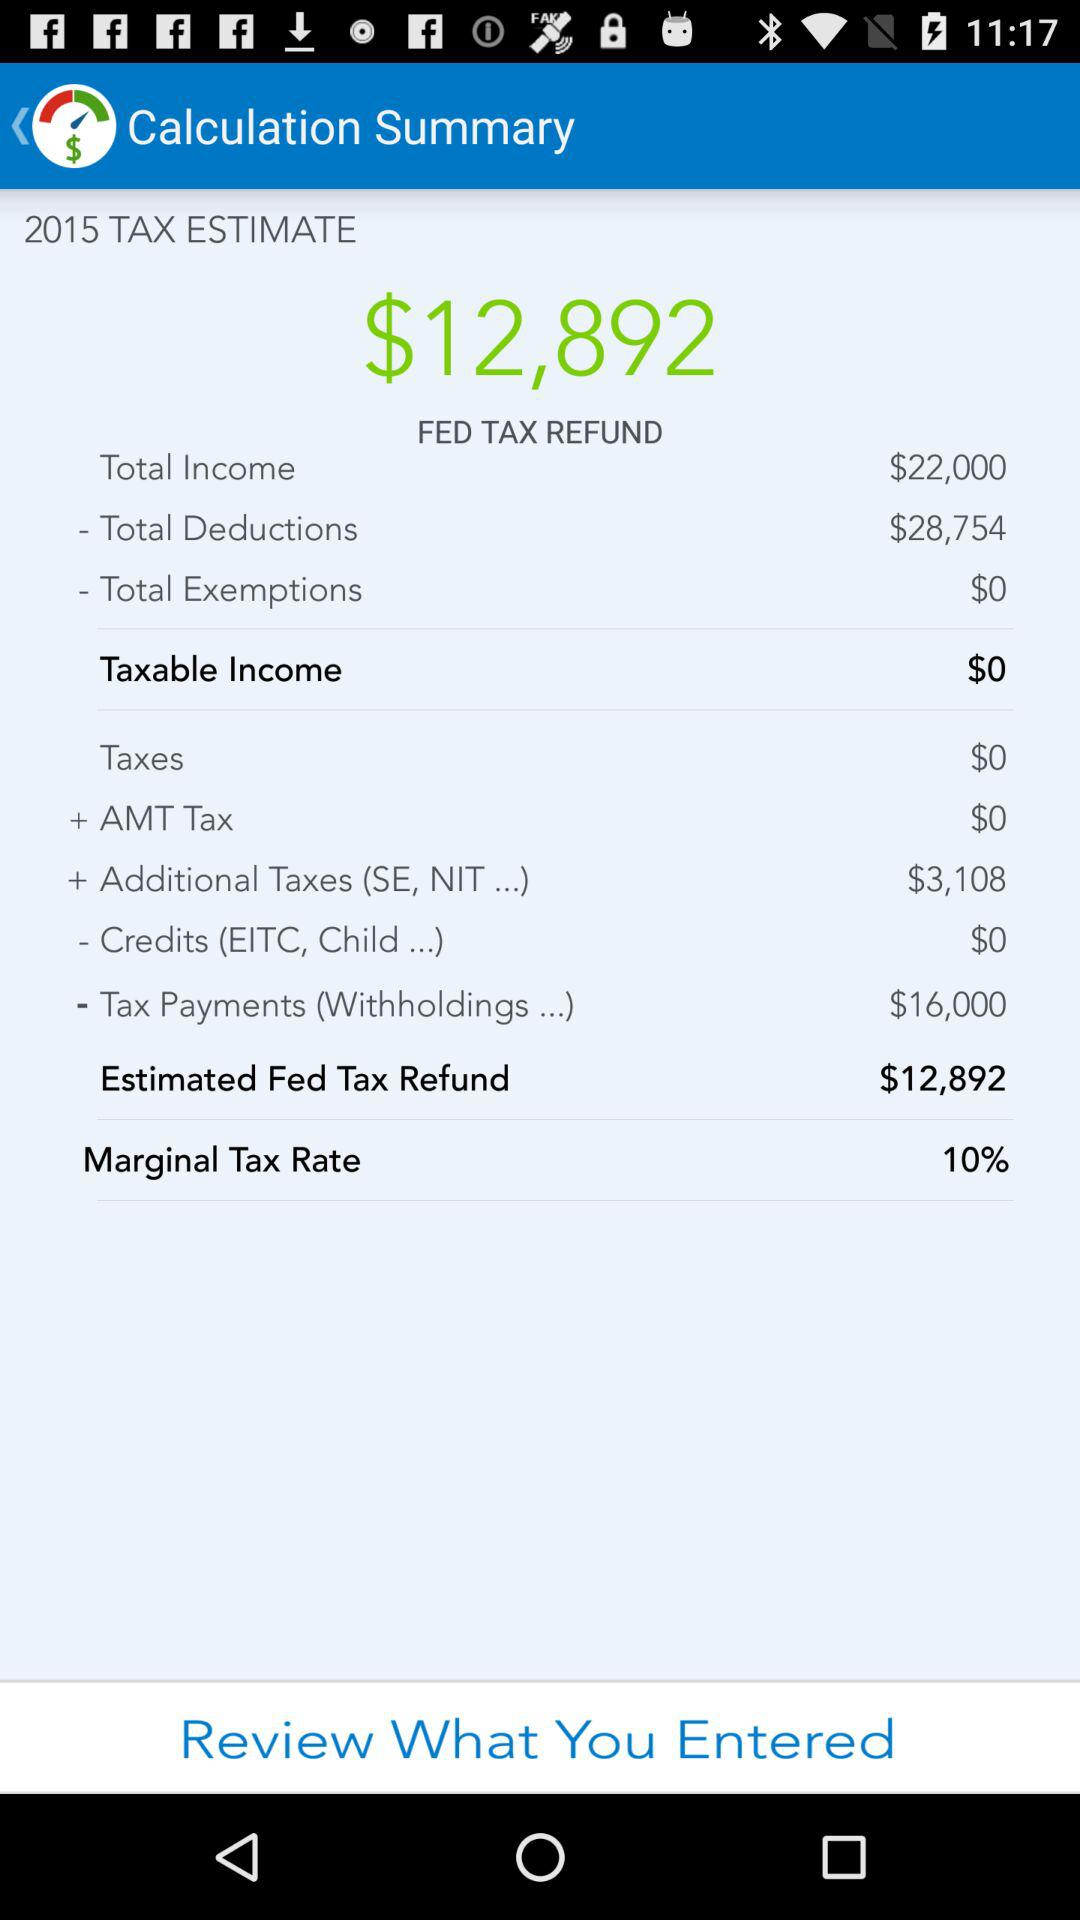What are the total deductions? The total deductions are $28,754. 